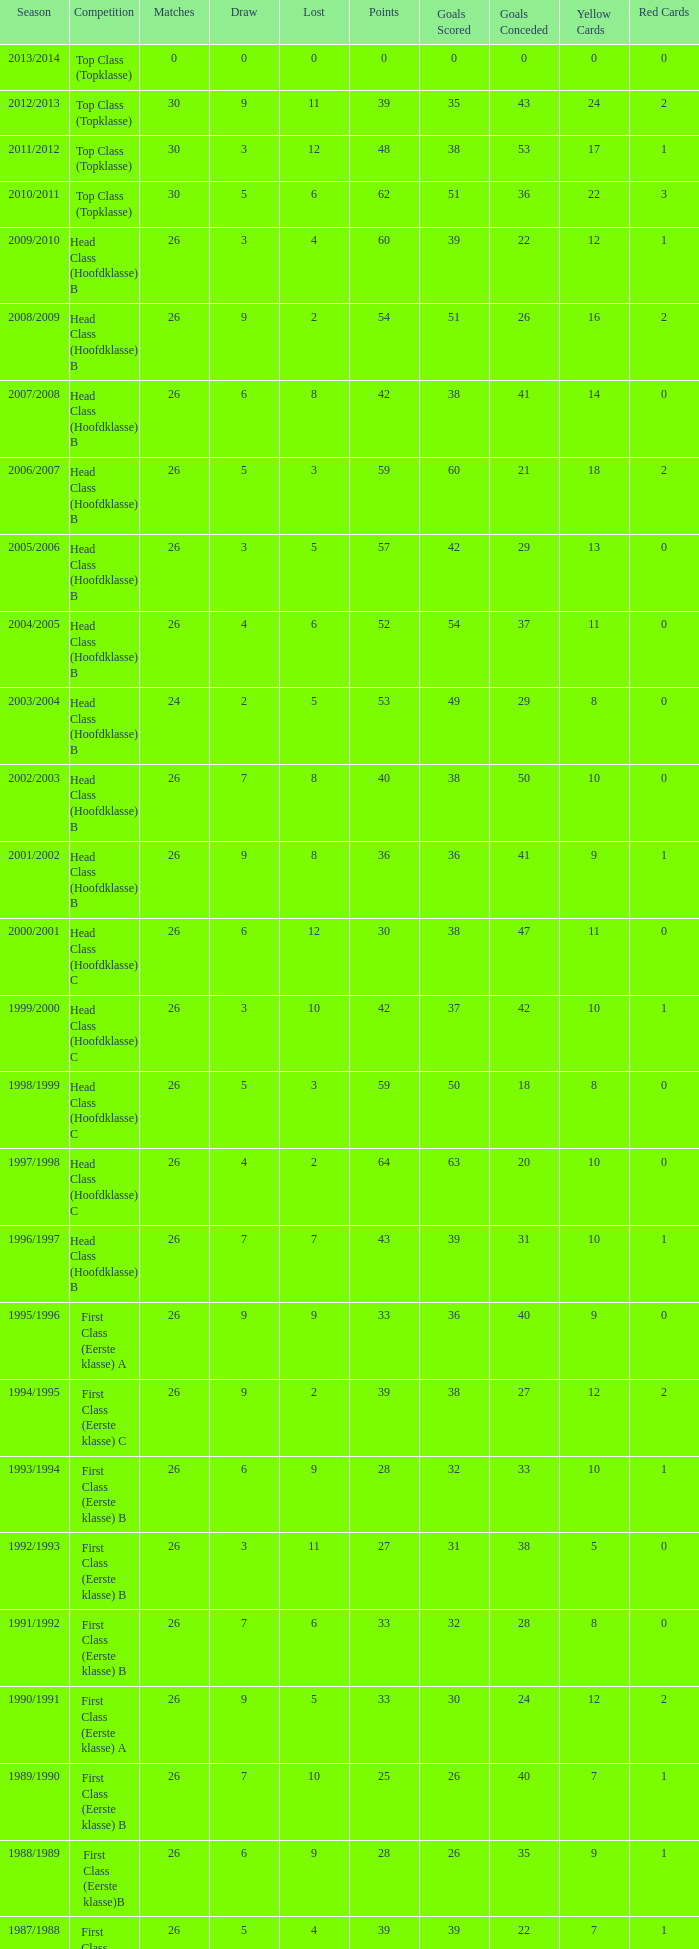What is the overall count of games with a defeat under 5 in the 2008/2009 season and possesses a tie greater than 9? 0.0. 